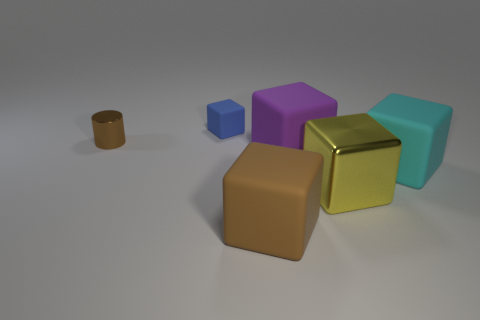If these objects were part of a game, what kind of game do you think it could be? Considering the shapes and colors, these objects could be part of a puzzle game that challenges the player to correctly match objects based on specific attributes, such as color, material, or shape, under the soft light that provides comfort and minimal distraction during gameplay. 